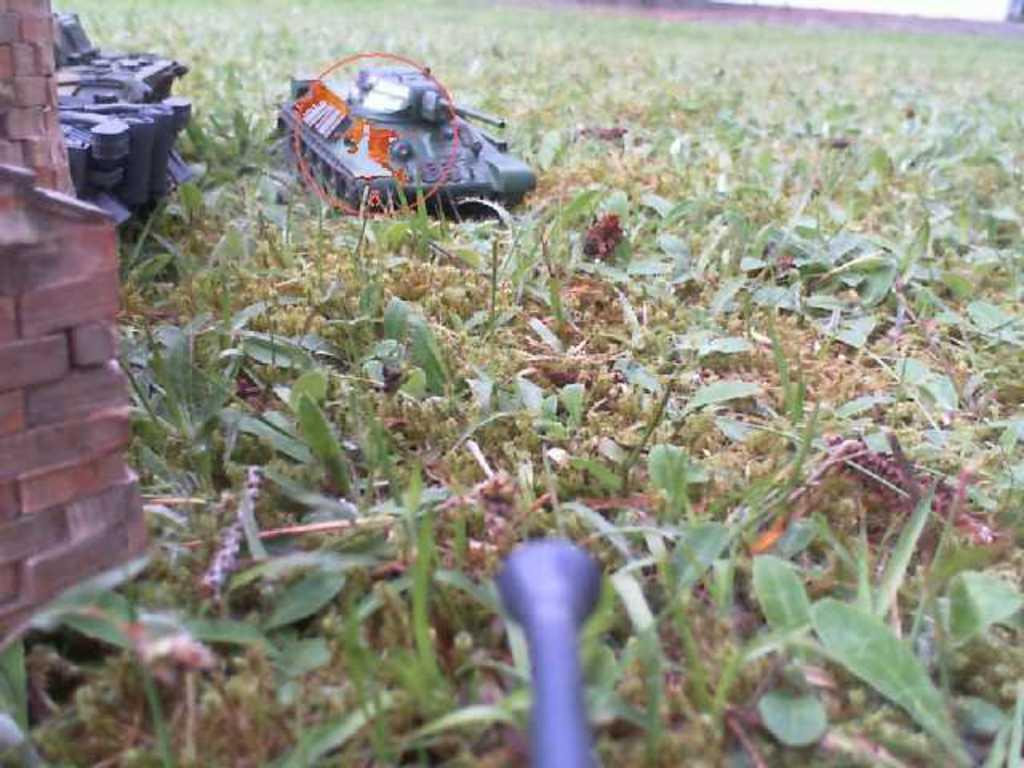What type of plants are on the ground in the image? There are small plants on the ground in the image. What toy vehicle is located on the left side of the image? There is a toy military tank vehicle on the left side of the image. What else can be found on the ground in the image? There are small bricks on the ground. Can you describe the object on the ground in the image? There is an object on the ground, but its description is not provided in the facts. What is the other object located at the bottom of the image? There is another object at the bottom of the image, but its description is not provided in the facts. What type of dress is the toy military tank vehicle wearing in the image? There is no dress present in the image, as the main subject is a toy military tank vehicle, which does not wear clothing. 